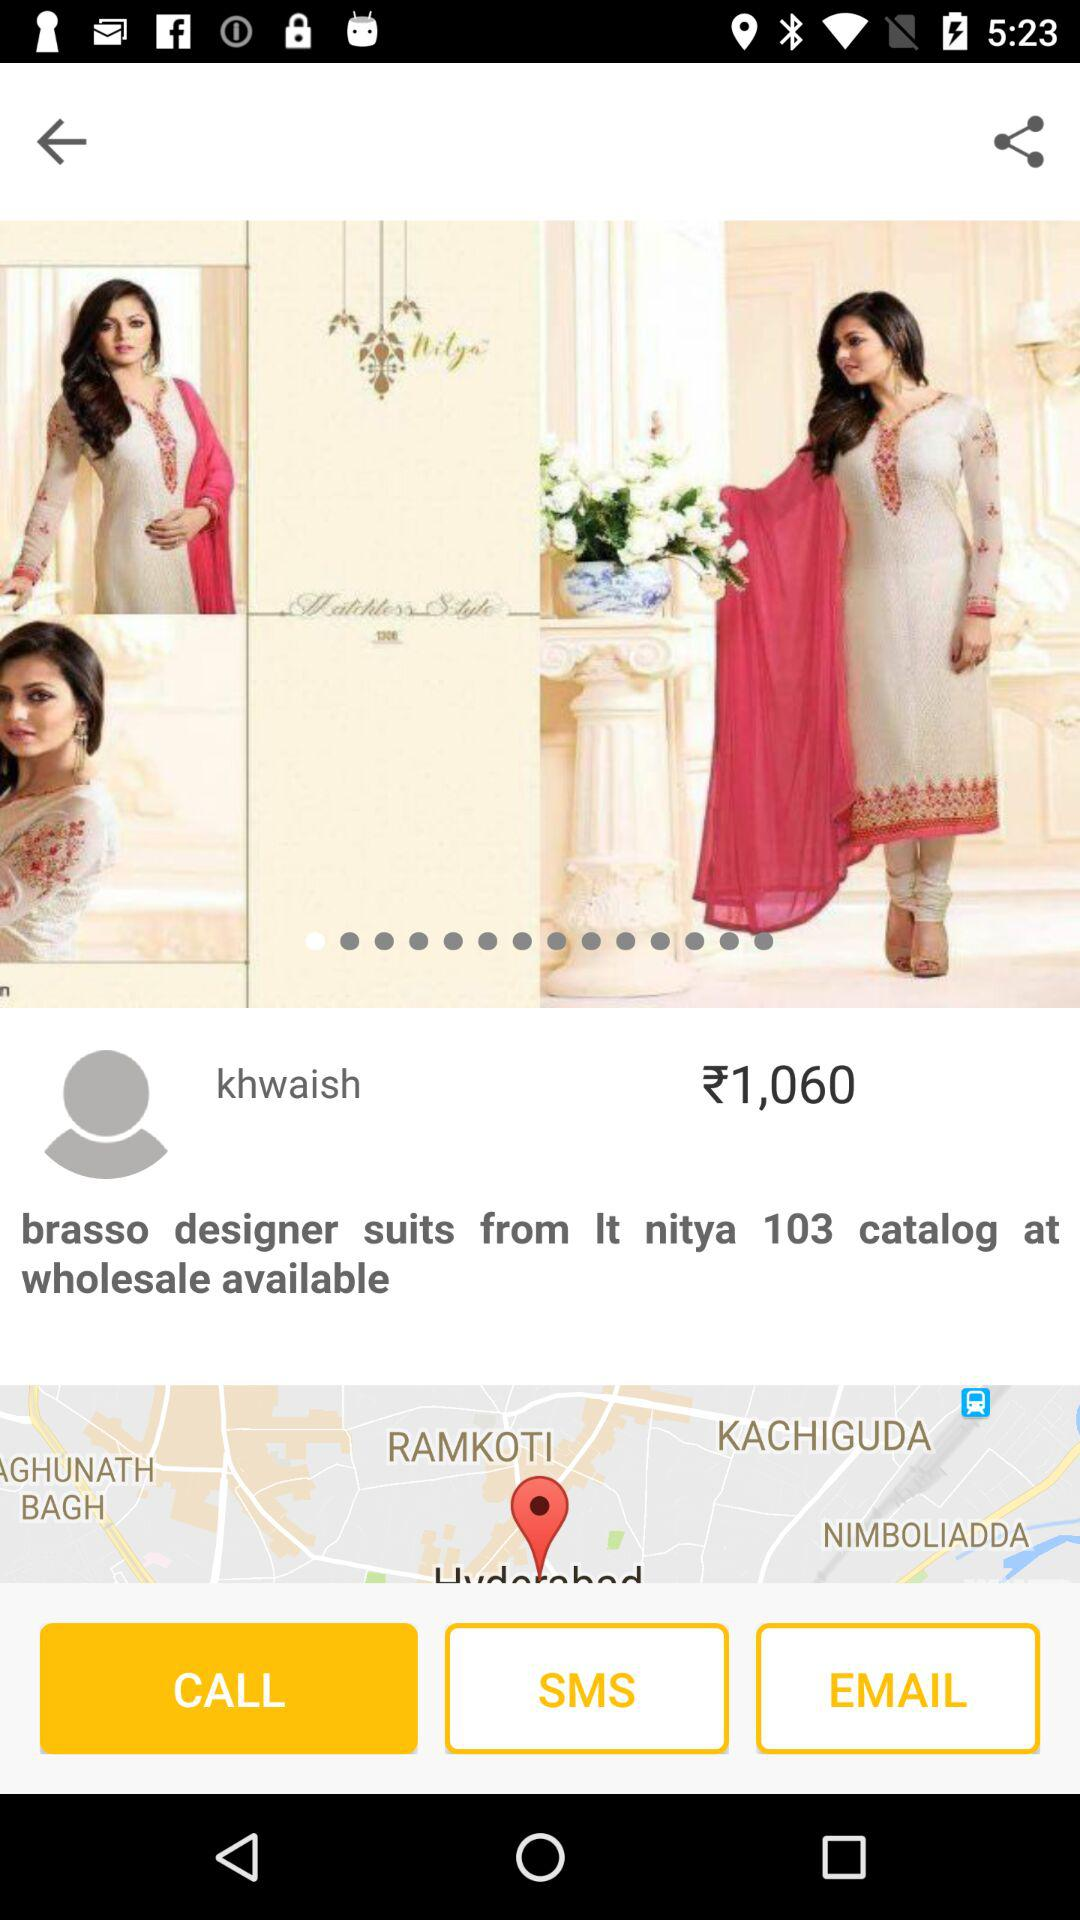How much is the price of this product?
Answer the question using a single word or phrase. ₹1,060 